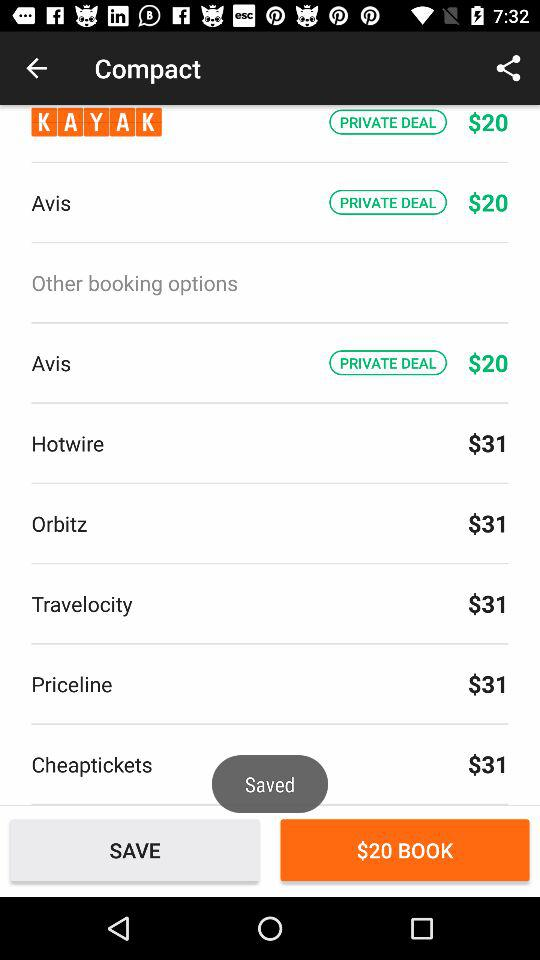What is the price of the booking through "Hotwire"? The price of the booking through "Hotwire" is $31. 